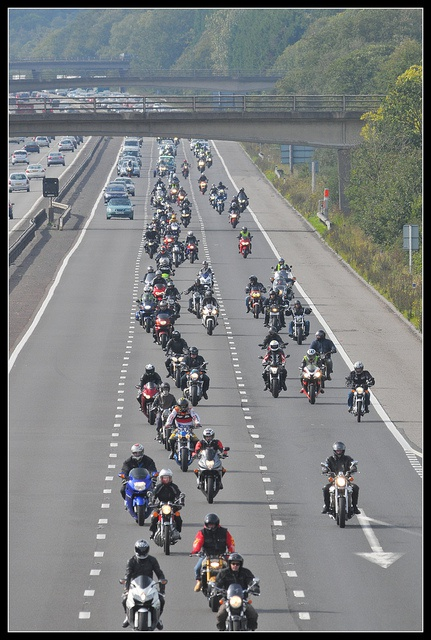Describe the objects in this image and their specific colors. I can see people in black, darkgray, and gray tones, motorcycle in black, darkgray, gray, and white tones, motorcycle in black, darkgray, gray, and navy tones, motorcycle in black, gray, darkgray, and lightgray tones, and motorcycle in black, gray, darkgray, and lightgray tones in this image. 